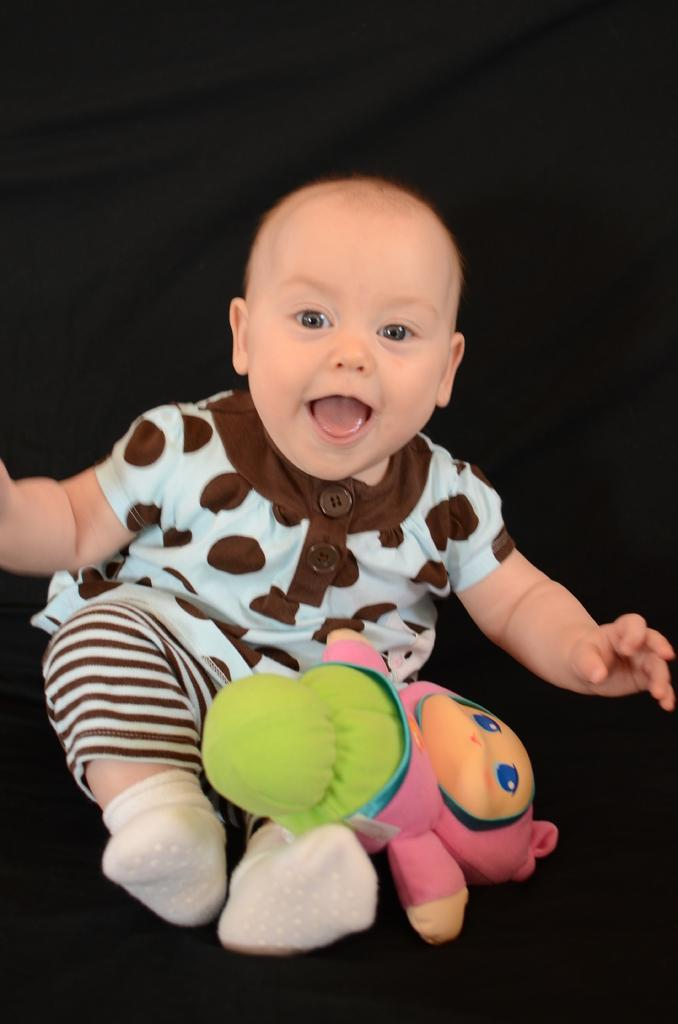What is the main subject of the image? The main subject of the image is a baby. What is the baby wearing in the image? The baby is wearing clothes and socks in the image. What can be seen in the image besides the baby? There is a toy in the image. What is the baby's facial expression in the image? The baby is smiling in the image. What type of wool is the baby's lawyer using to knit a scarf in the image? There is no wool, lawyer, or scarf present in the image; it features a baby wearing clothes and socks, smiling, and accompanied by a toy. 